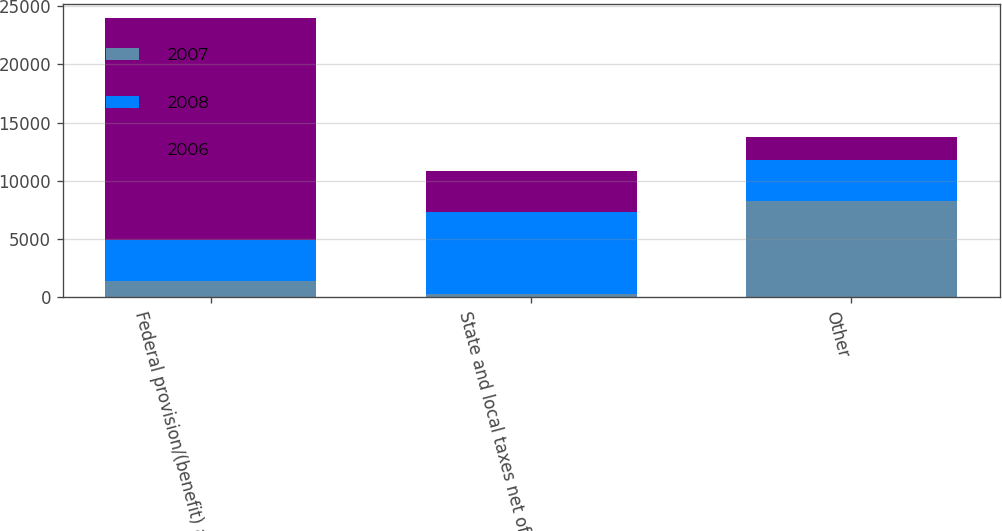Convert chart. <chart><loc_0><loc_0><loc_500><loc_500><stacked_bar_chart><ecel><fcel>Federal provision/(benefit) at<fcel>State and local taxes net of<fcel>Other<nl><fcel>2007<fcel>1390<fcel>258<fcel>8283<nl><fcel>2008<fcel>3548<fcel>7089<fcel>3552<nl><fcel>2006<fcel>19083<fcel>3544<fcel>1900<nl></chart> 